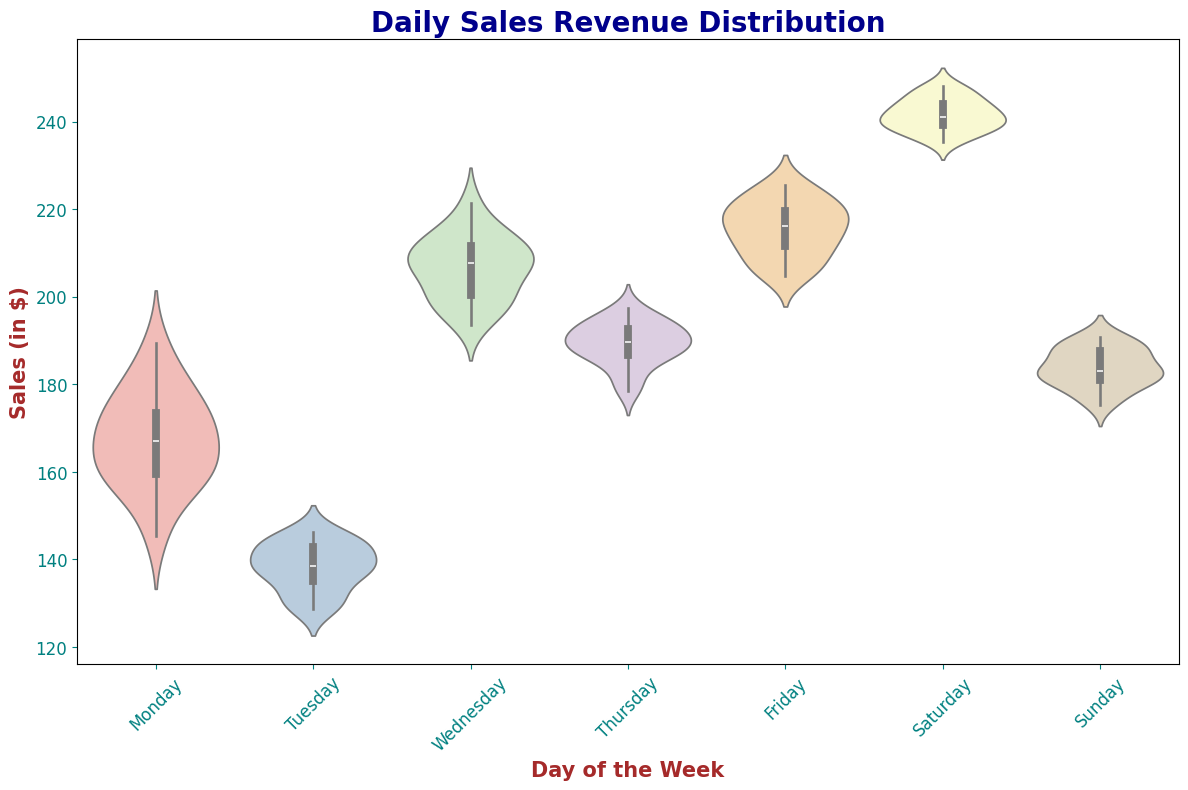what day has the highest median sales? The median value of the sales is represented by the width of the bulge in the violin plot. Saturday shows the widest bulge around the midpoint, indicating the highest median sales.
Answer: Saturday which day has the smallest range of daily sales revenue? The range of daily sales revenue is represented by the height of the violin plot. Thursday has the shortest height, indicating the smallest range.
Answer: Thursday how do the interquartile ranges of Monday and Wednesday compare? The interquartile range (IQR) can be observed by the width of the middle section of the violin plots. Wednesday’s IQR appears much wider than Monday’s, suggesting a larger spread in middle 50% of the data.
Answer: Wednesday's IQR is larger which day of the week has the most variability in daily sales revenue? Variability can be interpreted by the overall width and spread of the violin plot. Friday shows a very wide and spread out violin plot, indicating the highest variability in daily sales revenue.
Answer: Friday are there any days with similar median sales? Tuesday and Sunday have similar widths around the midpoint of their violin plots, suggesting similar medians.
Answer: Tuesday and Sunday which days have median sales greater than $200? The median sales appear as bulges in the center areas of the violin plots. Wednesday, Friday, and Saturday have bulges well above the $200 mark indicating medians above $200.
Answer: Wednesday, Friday, and Saturday is there a notable outlier in any of the days? Outliers appear as very small, isolated points or bulbs. None of the days display such a pattern distinct from the main body of the violin plot, suggesting no prominent outliers.
Answer: No notable outliers what is the median sales value for Tuesdays if the value falls at the narrowest part of the middle section of the plot? The narrowest part of the middle section of Tuesday’s violin plot appears around the $138-$140 mark, indicating the median value.
Answer: $138-$140 